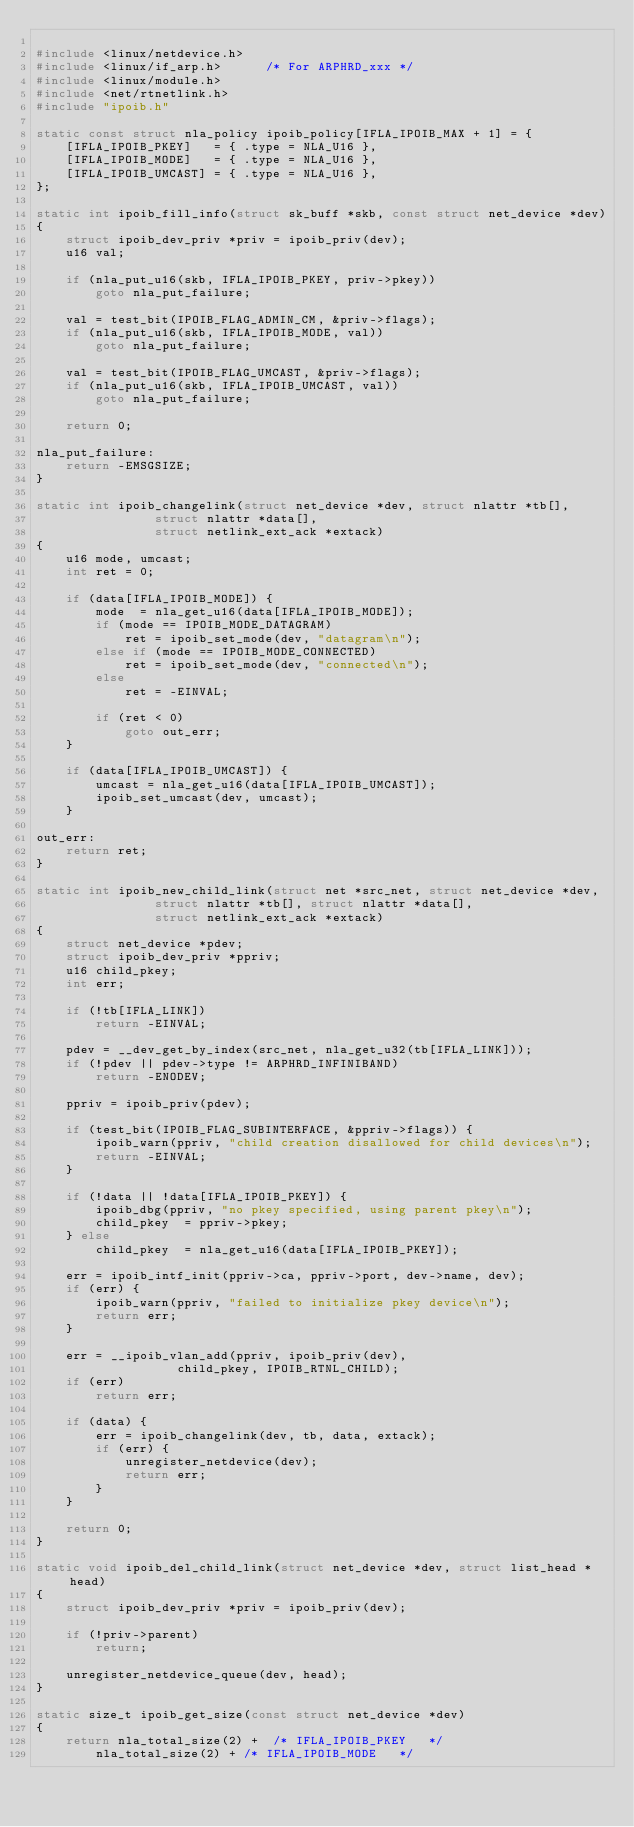<code> <loc_0><loc_0><loc_500><loc_500><_C_>
#include <linux/netdevice.h>
#include <linux/if_arp.h>      /* For ARPHRD_xxx */
#include <linux/module.h>
#include <net/rtnetlink.h>
#include "ipoib.h"

static const struct nla_policy ipoib_policy[IFLA_IPOIB_MAX + 1] = {
	[IFLA_IPOIB_PKEY]	= { .type = NLA_U16 },
	[IFLA_IPOIB_MODE]	= { .type = NLA_U16 },
	[IFLA_IPOIB_UMCAST]	= { .type = NLA_U16 },
};

static int ipoib_fill_info(struct sk_buff *skb, const struct net_device *dev)
{
	struct ipoib_dev_priv *priv = ipoib_priv(dev);
	u16 val;

	if (nla_put_u16(skb, IFLA_IPOIB_PKEY, priv->pkey))
		goto nla_put_failure;

	val = test_bit(IPOIB_FLAG_ADMIN_CM, &priv->flags);
	if (nla_put_u16(skb, IFLA_IPOIB_MODE, val))
		goto nla_put_failure;

	val = test_bit(IPOIB_FLAG_UMCAST, &priv->flags);
	if (nla_put_u16(skb, IFLA_IPOIB_UMCAST, val))
		goto nla_put_failure;

	return 0;

nla_put_failure:
	return -EMSGSIZE;
}

static int ipoib_changelink(struct net_device *dev, struct nlattr *tb[],
			    struct nlattr *data[],
			    struct netlink_ext_ack *extack)
{
	u16 mode, umcast;
	int ret = 0;

	if (data[IFLA_IPOIB_MODE]) {
		mode  = nla_get_u16(data[IFLA_IPOIB_MODE]);
		if (mode == IPOIB_MODE_DATAGRAM)
			ret = ipoib_set_mode(dev, "datagram\n");
		else if (mode == IPOIB_MODE_CONNECTED)
			ret = ipoib_set_mode(dev, "connected\n");
		else
			ret = -EINVAL;

		if (ret < 0)
			goto out_err;
	}

	if (data[IFLA_IPOIB_UMCAST]) {
		umcast = nla_get_u16(data[IFLA_IPOIB_UMCAST]);
		ipoib_set_umcast(dev, umcast);
	}

out_err:
	return ret;
}

static int ipoib_new_child_link(struct net *src_net, struct net_device *dev,
				struct nlattr *tb[], struct nlattr *data[],
				struct netlink_ext_ack *extack)
{
	struct net_device *pdev;
	struct ipoib_dev_priv *ppriv;
	u16 child_pkey;
	int err;

	if (!tb[IFLA_LINK])
		return -EINVAL;

	pdev = __dev_get_by_index(src_net, nla_get_u32(tb[IFLA_LINK]));
	if (!pdev || pdev->type != ARPHRD_INFINIBAND)
		return -ENODEV;

	ppriv = ipoib_priv(pdev);

	if (test_bit(IPOIB_FLAG_SUBINTERFACE, &ppriv->flags)) {
		ipoib_warn(ppriv, "child creation disallowed for child devices\n");
		return -EINVAL;
	}

	if (!data || !data[IFLA_IPOIB_PKEY]) {
		ipoib_dbg(ppriv, "no pkey specified, using parent pkey\n");
		child_pkey  = ppriv->pkey;
	} else
		child_pkey  = nla_get_u16(data[IFLA_IPOIB_PKEY]);

	err = ipoib_intf_init(ppriv->ca, ppriv->port, dev->name, dev);
	if (err) {
		ipoib_warn(ppriv, "failed to initialize pkey device\n");
		return err;
	}

	err = __ipoib_vlan_add(ppriv, ipoib_priv(dev),
			       child_pkey, IPOIB_RTNL_CHILD);
	if (err)
		return err;

	if (data) {
		err = ipoib_changelink(dev, tb, data, extack);
		if (err) {
			unregister_netdevice(dev);
			return err;
		}
	}

	return 0;
}

static void ipoib_del_child_link(struct net_device *dev, struct list_head *head)
{
	struct ipoib_dev_priv *priv = ipoib_priv(dev);

	if (!priv->parent)
		return;

	unregister_netdevice_queue(dev, head);
}

static size_t ipoib_get_size(const struct net_device *dev)
{
	return nla_total_size(2) +	/* IFLA_IPOIB_PKEY   */
		nla_total_size(2) +	/* IFLA_IPOIB_MODE   */</code> 